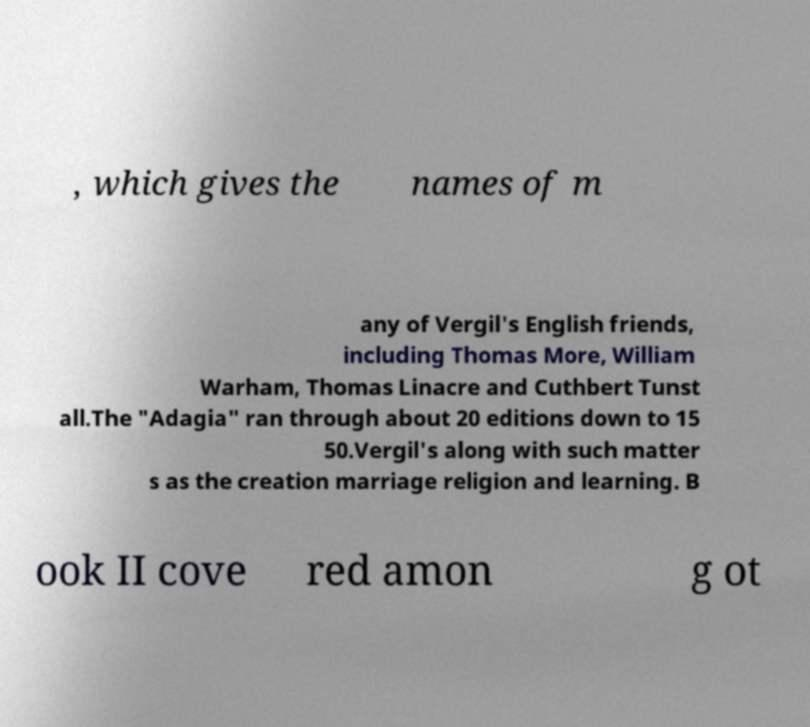For documentation purposes, I need the text within this image transcribed. Could you provide that? , which gives the names of m any of Vergil's English friends, including Thomas More, William Warham, Thomas Linacre and Cuthbert Tunst all.The "Adagia" ran through about 20 editions down to 15 50.Vergil's along with such matter s as the creation marriage religion and learning. B ook II cove red amon g ot 